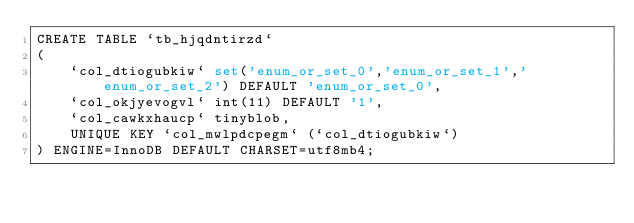Convert code to text. <code><loc_0><loc_0><loc_500><loc_500><_SQL_>CREATE TABLE `tb_hjqdntirzd`
(
    `col_dtiogubkiw` set('enum_or_set_0','enum_or_set_1','enum_or_set_2') DEFAULT 'enum_or_set_0',
    `col_okjyevogvl` int(11) DEFAULT '1',
    `col_cawkxhaucp` tinyblob,
    UNIQUE KEY `col_mwlpdcpegm` (`col_dtiogubkiw`)
) ENGINE=InnoDB DEFAULT CHARSET=utf8mb4;
</code> 